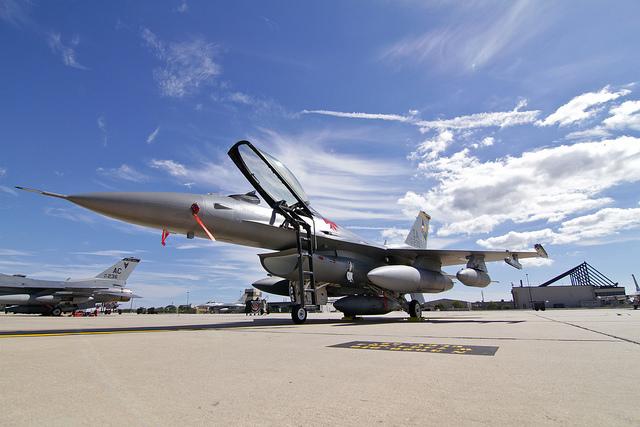What is that ladder-looking thing?
Write a very short answer. Ladder. What is the main color of the plane?
Write a very short answer. Gray. Is this a jet plane?
Short answer required. Yes. How many planes are in the picture?
Be succinct. 2. What color is the plane?
Answer briefly. Silver. What is the weather like in this scene?
Short answer required. Sunny. 